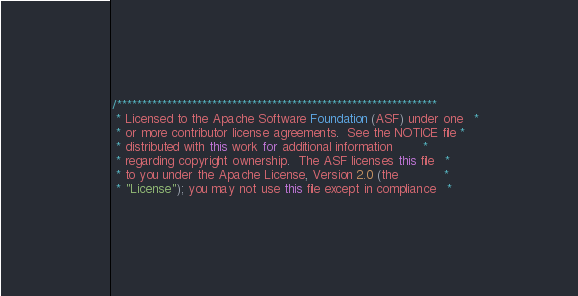Convert code to text. <code><loc_0><loc_0><loc_500><loc_500><_Java_>/****************************************************************
 * Licensed to the Apache Software Foundation (ASF) under one   *
 * or more contributor license agreements.  See the NOTICE file *
 * distributed with this work for additional information        *
 * regarding copyright ownership.  The ASF licenses this file   *
 * to you under the Apache License, Version 2.0 (the            *
 * "License"); you may not use this file except in compliance   *</code> 